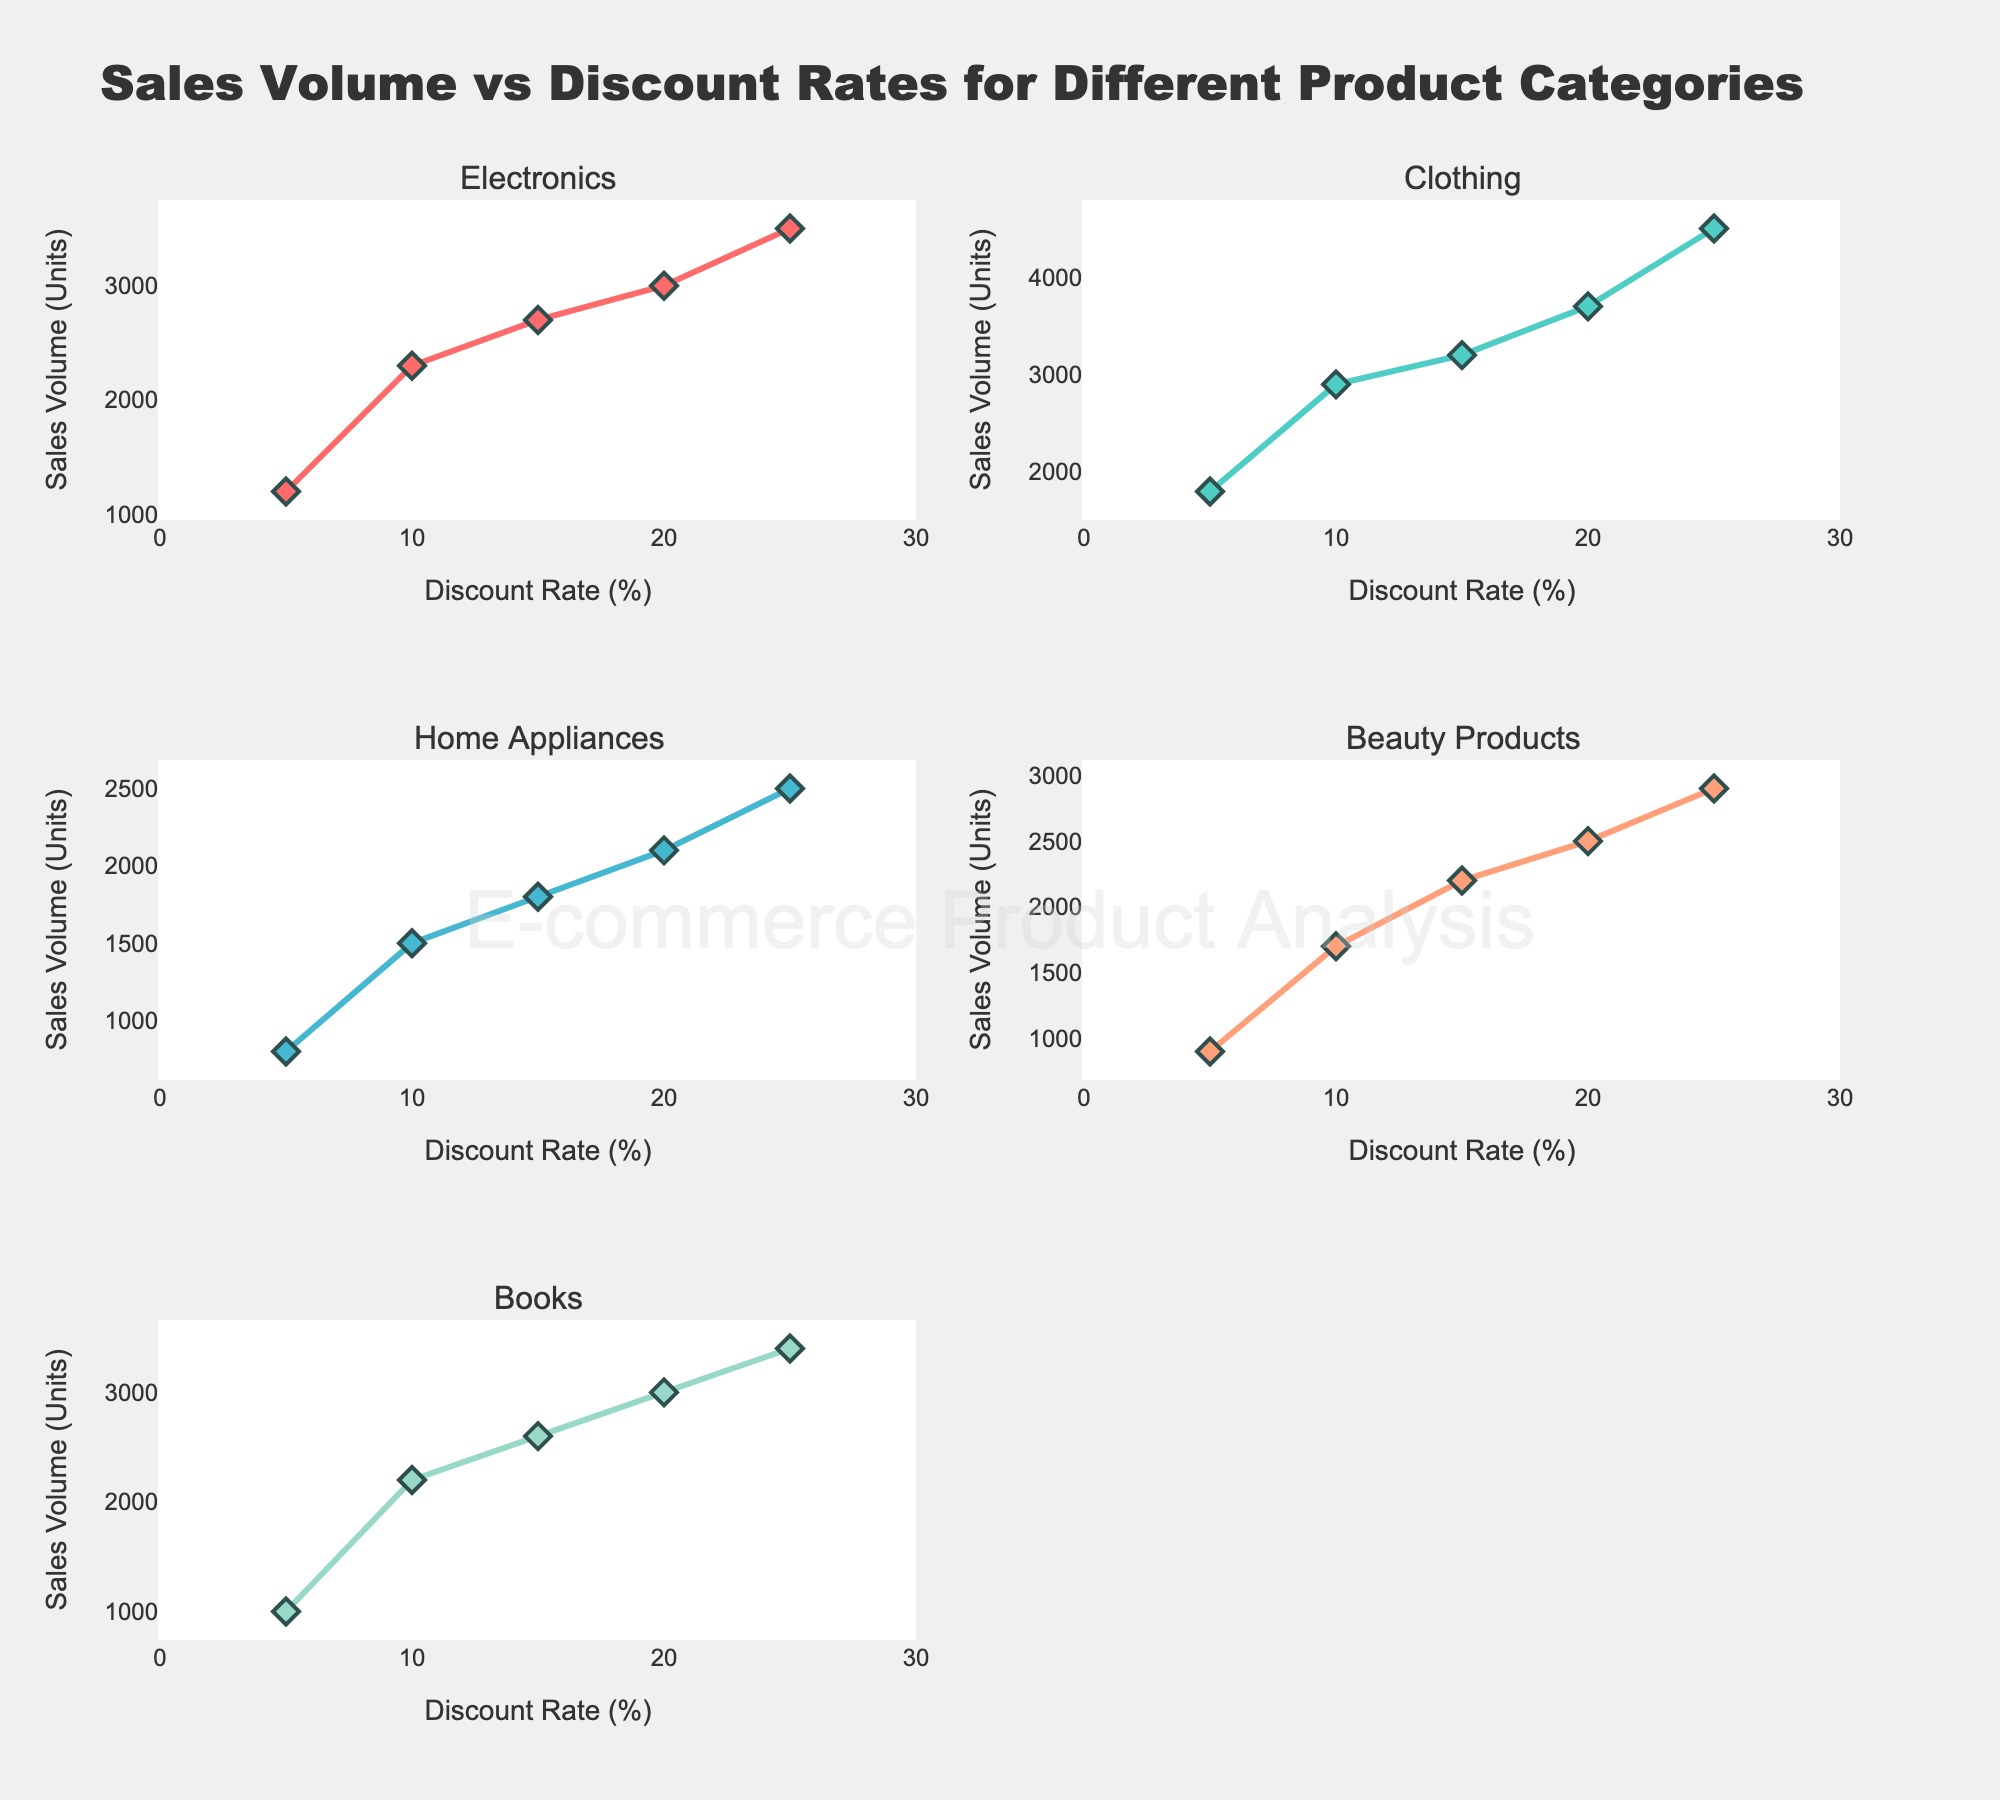What is the title of the figure? The title is located at the top of the figure and it's clearly mentioned.
Answer: Sales Volume vs Discount Rates for Different Product Categories Which product category shows the highest sales volume at a 25% discount rate? Look for the data points at a 25% discount rate in each subplot and identify the maximum y-value. Clothing has the highest sales volume at this discount rate, with 4500 units.
Answer: Clothing How does the sales volume of Electronics change as the discount rate increases? Observe the Electronics subplot and note the trend of the data points. The sales volume increases as the discount rate increases.
Answer: Increases What is the range of discount rates displayed on the x-axes of the subplots? Each subplot has the same x-axis ranging from 0 to 30% discount rate, which is indicated by the x-axis range in the figure.
Answer: 0 to 30% Compare the sales volumes of Beauty Products and Books when the discount rate is 10%. Which one is higher and by how much? Identify the data points for Beauty Products and Books at the 10% discount rate. Beauty Products have 1700 units and Books have 2200 units. The difference is 2200 - 1700 = 500 units.
Answer: Books by 500 units How many unique product categories are represented in the figure? Count the number of unique subplots or check the subplot titles, each representing a different category. There are 5 unique product categories.
Answer: 5 What can you infer about the relationship between discount rate and sales volume in Home Appliances? Examine the trend in the Home Appliances subplot. The sales volume increases more steadily as the discount rate goes up, indicating a positive relationship.
Answer: Positive relationship At which discount rate do Beauty Products and Electronics have the same sales volume? Look at the intersection points where the sales volume (y-values) of Beauty Products and Electronics align. It occurs at a 20% discount rate, with both having 2500 units.
Answer: 20% Is there any product category where sales volume decreases with an increase in the discount rate? Inspect all subplots for any category showing a downward trend. None of the categories show a decrease; sales volumes increase with higher discount rates.
Answer: No What is the average sales volume for Clothing across all discount rates? Sum all sales volumes for Clothing and divide by the number of data points. (1800 + 2900 + 3200 + 3700 + 4500) / 5 = 3220 units.
Answer: 3220 units 